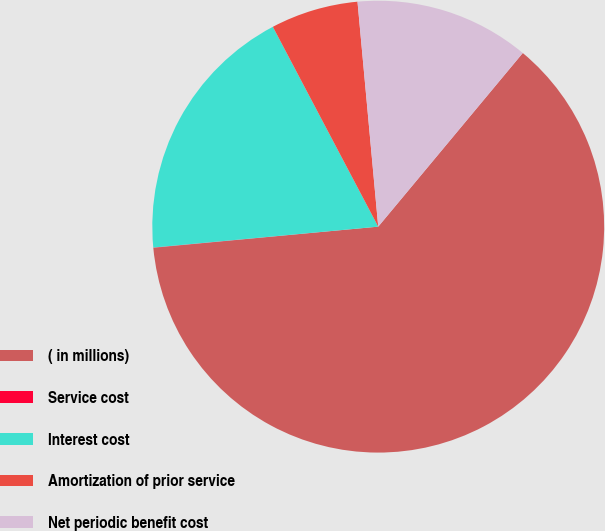Convert chart to OTSL. <chart><loc_0><loc_0><loc_500><loc_500><pie_chart><fcel>( in millions)<fcel>Service cost<fcel>Interest cost<fcel>Amortization of prior service<fcel>Net periodic benefit cost<nl><fcel>62.45%<fcel>0.02%<fcel>18.75%<fcel>6.26%<fcel>12.51%<nl></chart> 